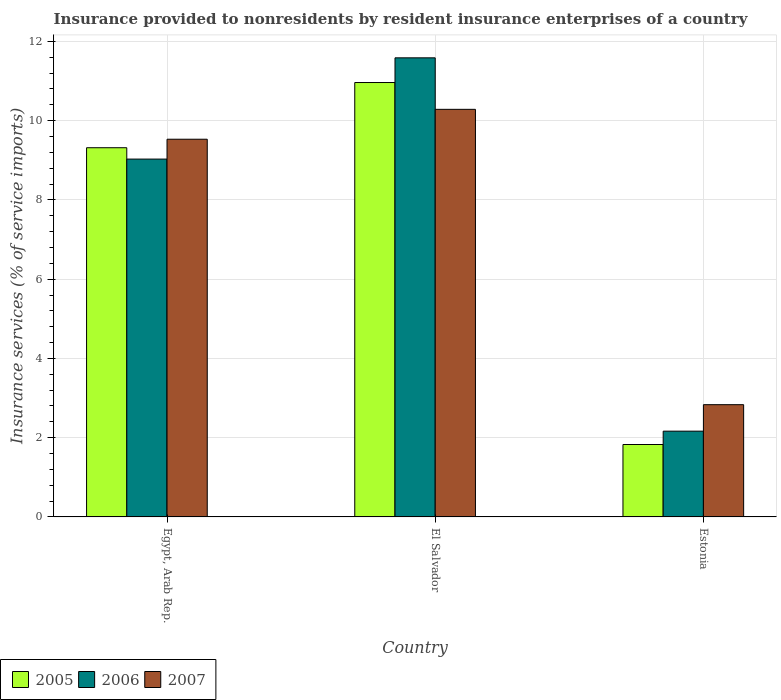How many different coloured bars are there?
Keep it short and to the point. 3. How many groups of bars are there?
Provide a succinct answer. 3. How many bars are there on the 2nd tick from the right?
Make the answer very short. 3. What is the label of the 2nd group of bars from the left?
Make the answer very short. El Salvador. In how many cases, is the number of bars for a given country not equal to the number of legend labels?
Your answer should be compact. 0. What is the insurance provided to nonresidents in 2005 in Estonia?
Your answer should be very brief. 1.83. Across all countries, what is the maximum insurance provided to nonresidents in 2007?
Keep it short and to the point. 10.29. Across all countries, what is the minimum insurance provided to nonresidents in 2007?
Your response must be concise. 2.83. In which country was the insurance provided to nonresidents in 2007 maximum?
Offer a terse response. El Salvador. In which country was the insurance provided to nonresidents in 2007 minimum?
Ensure brevity in your answer.  Estonia. What is the total insurance provided to nonresidents in 2007 in the graph?
Provide a short and direct response. 22.65. What is the difference between the insurance provided to nonresidents in 2007 in Egypt, Arab Rep. and that in Estonia?
Keep it short and to the point. 6.7. What is the difference between the insurance provided to nonresidents in 2006 in El Salvador and the insurance provided to nonresidents in 2005 in Estonia?
Give a very brief answer. 9.76. What is the average insurance provided to nonresidents in 2007 per country?
Your answer should be very brief. 7.55. What is the difference between the insurance provided to nonresidents of/in 2005 and insurance provided to nonresidents of/in 2007 in El Salvador?
Provide a short and direct response. 0.68. What is the ratio of the insurance provided to nonresidents in 2007 in Egypt, Arab Rep. to that in Estonia?
Offer a terse response. 3.36. Is the difference between the insurance provided to nonresidents in 2005 in Egypt, Arab Rep. and Estonia greater than the difference between the insurance provided to nonresidents in 2007 in Egypt, Arab Rep. and Estonia?
Your response must be concise. Yes. What is the difference between the highest and the second highest insurance provided to nonresidents in 2006?
Your answer should be compact. 6.87. What is the difference between the highest and the lowest insurance provided to nonresidents in 2006?
Your answer should be compact. 9.42. What does the 3rd bar from the left in Egypt, Arab Rep. represents?
Give a very brief answer. 2007. How many countries are there in the graph?
Provide a short and direct response. 3. Are the values on the major ticks of Y-axis written in scientific E-notation?
Ensure brevity in your answer.  No. Does the graph contain any zero values?
Offer a terse response. No. Does the graph contain grids?
Give a very brief answer. Yes. Where does the legend appear in the graph?
Ensure brevity in your answer.  Bottom left. How are the legend labels stacked?
Your answer should be very brief. Horizontal. What is the title of the graph?
Offer a very short reply. Insurance provided to nonresidents by resident insurance enterprises of a country. What is the label or title of the Y-axis?
Offer a very short reply. Insurance services (% of service imports). What is the Insurance services (% of service imports) in 2005 in Egypt, Arab Rep.?
Offer a terse response. 9.32. What is the Insurance services (% of service imports) of 2006 in Egypt, Arab Rep.?
Provide a succinct answer. 9.03. What is the Insurance services (% of service imports) in 2007 in Egypt, Arab Rep.?
Give a very brief answer. 9.53. What is the Insurance services (% of service imports) in 2005 in El Salvador?
Keep it short and to the point. 10.96. What is the Insurance services (% of service imports) of 2006 in El Salvador?
Offer a very short reply. 11.59. What is the Insurance services (% of service imports) in 2007 in El Salvador?
Make the answer very short. 10.29. What is the Insurance services (% of service imports) of 2005 in Estonia?
Offer a very short reply. 1.83. What is the Insurance services (% of service imports) in 2006 in Estonia?
Offer a terse response. 2.16. What is the Insurance services (% of service imports) of 2007 in Estonia?
Provide a succinct answer. 2.83. Across all countries, what is the maximum Insurance services (% of service imports) of 2005?
Give a very brief answer. 10.96. Across all countries, what is the maximum Insurance services (% of service imports) of 2006?
Your answer should be compact. 11.59. Across all countries, what is the maximum Insurance services (% of service imports) in 2007?
Offer a very short reply. 10.29. Across all countries, what is the minimum Insurance services (% of service imports) of 2005?
Offer a very short reply. 1.83. Across all countries, what is the minimum Insurance services (% of service imports) of 2006?
Make the answer very short. 2.16. Across all countries, what is the minimum Insurance services (% of service imports) in 2007?
Your answer should be compact. 2.83. What is the total Insurance services (% of service imports) of 2005 in the graph?
Offer a very short reply. 22.11. What is the total Insurance services (% of service imports) of 2006 in the graph?
Keep it short and to the point. 22.78. What is the total Insurance services (% of service imports) in 2007 in the graph?
Provide a short and direct response. 22.65. What is the difference between the Insurance services (% of service imports) of 2005 in Egypt, Arab Rep. and that in El Salvador?
Your answer should be compact. -1.65. What is the difference between the Insurance services (% of service imports) of 2006 in Egypt, Arab Rep. and that in El Salvador?
Your response must be concise. -2.56. What is the difference between the Insurance services (% of service imports) in 2007 in Egypt, Arab Rep. and that in El Salvador?
Provide a short and direct response. -0.75. What is the difference between the Insurance services (% of service imports) in 2005 in Egypt, Arab Rep. and that in Estonia?
Your answer should be compact. 7.49. What is the difference between the Insurance services (% of service imports) of 2006 in Egypt, Arab Rep. and that in Estonia?
Offer a terse response. 6.87. What is the difference between the Insurance services (% of service imports) of 2007 in Egypt, Arab Rep. and that in Estonia?
Keep it short and to the point. 6.7. What is the difference between the Insurance services (% of service imports) in 2005 in El Salvador and that in Estonia?
Give a very brief answer. 9.13. What is the difference between the Insurance services (% of service imports) of 2006 in El Salvador and that in Estonia?
Make the answer very short. 9.42. What is the difference between the Insurance services (% of service imports) in 2007 in El Salvador and that in Estonia?
Your answer should be compact. 7.45. What is the difference between the Insurance services (% of service imports) of 2005 in Egypt, Arab Rep. and the Insurance services (% of service imports) of 2006 in El Salvador?
Provide a short and direct response. -2.27. What is the difference between the Insurance services (% of service imports) in 2005 in Egypt, Arab Rep. and the Insurance services (% of service imports) in 2007 in El Salvador?
Ensure brevity in your answer.  -0.97. What is the difference between the Insurance services (% of service imports) in 2006 in Egypt, Arab Rep. and the Insurance services (% of service imports) in 2007 in El Salvador?
Provide a short and direct response. -1.26. What is the difference between the Insurance services (% of service imports) of 2005 in Egypt, Arab Rep. and the Insurance services (% of service imports) of 2006 in Estonia?
Your answer should be very brief. 7.15. What is the difference between the Insurance services (% of service imports) of 2005 in Egypt, Arab Rep. and the Insurance services (% of service imports) of 2007 in Estonia?
Your response must be concise. 6.48. What is the difference between the Insurance services (% of service imports) of 2006 in Egypt, Arab Rep. and the Insurance services (% of service imports) of 2007 in Estonia?
Offer a terse response. 6.2. What is the difference between the Insurance services (% of service imports) of 2005 in El Salvador and the Insurance services (% of service imports) of 2006 in Estonia?
Provide a succinct answer. 8.8. What is the difference between the Insurance services (% of service imports) of 2005 in El Salvador and the Insurance services (% of service imports) of 2007 in Estonia?
Your answer should be very brief. 8.13. What is the difference between the Insurance services (% of service imports) of 2006 in El Salvador and the Insurance services (% of service imports) of 2007 in Estonia?
Offer a very short reply. 8.75. What is the average Insurance services (% of service imports) of 2005 per country?
Keep it short and to the point. 7.37. What is the average Insurance services (% of service imports) in 2006 per country?
Your answer should be very brief. 7.59. What is the average Insurance services (% of service imports) in 2007 per country?
Offer a terse response. 7.55. What is the difference between the Insurance services (% of service imports) in 2005 and Insurance services (% of service imports) in 2006 in Egypt, Arab Rep.?
Your answer should be very brief. 0.29. What is the difference between the Insurance services (% of service imports) in 2005 and Insurance services (% of service imports) in 2007 in Egypt, Arab Rep.?
Give a very brief answer. -0.21. What is the difference between the Insurance services (% of service imports) in 2006 and Insurance services (% of service imports) in 2007 in Egypt, Arab Rep.?
Keep it short and to the point. -0.5. What is the difference between the Insurance services (% of service imports) of 2005 and Insurance services (% of service imports) of 2006 in El Salvador?
Your response must be concise. -0.62. What is the difference between the Insurance services (% of service imports) in 2005 and Insurance services (% of service imports) in 2007 in El Salvador?
Provide a succinct answer. 0.68. What is the difference between the Insurance services (% of service imports) in 2006 and Insurance services (% of service imports) in 2007 in El Salvador?
Provide a succinct answer. 1.3. What is the difference between the Insurance services (% of service imports) in 2005 and Insurance services (% of service imports) in 2006 in Estonia?
Your answer should be compact. -0.34. What is the difference between the Insurance services (% of service imports) of 2005 and Insurance services (% of service imports) of 2007 in Estonia?
Offer a terse response. -1.01. What is the difference between the Insurance services (% of service imports) in 2006 and Insurance services (% of service imports) in 2007 in Estonia?
Offer a very short reply. -0.67. What is the ratio of the Insurance services (% of service imports) of 2005 in Egypt, Arab Rep. to that in El Salvador?
Offer a very short reply. 0.85. What is the ratio of the Insurance services (% of service imports) of 2006 in Egypt, Arab Rep. to that in El Salvador?
Keep it short and to the point. 0.78. What is the ratio of the Insurance services (% of service imports) of 2007 in Egypt, Arab Rep. to that in El Salvador?
Your answer should be very brief. 0.93. What is the ratio of the Insurance services (% of service imports) in 2005 in Egypt, Arab Rep. to that in Estonia?
Offer a very short reply. 5.1. What is the ratio of the Insurance services (% of service imports) in 2006 in Egypt, Arab Rep. to that in Estonia?
Make the answer very short. 4.17. What is the ratio of the Insurance services (% of service imports) of 2007 in Egypt, Arab Rep. to that in Estonia?
Give a very brief answer. 3.36. What is the ratio of the Insurance services (% of service imports) in 2005 in El Salvador to that in Estonia?
Provide a short and direct response. 6. What is the ratio of the Insurance services (% of service imports) of 2006 in El Salvador to that in Estonia?
Make the answer very short. 5.35. What is the ratio of the Insurance services (% of service imports) in 2007 in El Salvador to that in Estonia?
Your response must be concise. 3.63. What is the difference between the highest and the second highest Insurance services (% of service imports) of 2005?
Ensure brevity in your answer.  1.65. What is the difference between the highest and the second highest Insurance services (% of service imports) of 2006?
Ensure brevity in your answer.  2.56. What is the difference between the highest and the second highest Insurance services (% of service imports) in 2007?
Ensure brevity in your answer.  0.75. What is the difference between the highest and the lowest Insurance services (% of service imports) of 2005?
Give a very brief answer. 9.13. What is the difference between the highest and the lowest Insurance services (% of service imports) in 2006?
Make the answer very short. 9.42. What is the difference between the highest and the lowest Insurance services (% of service imports) in 2007?
Keep it short and to the point. 7.45. 